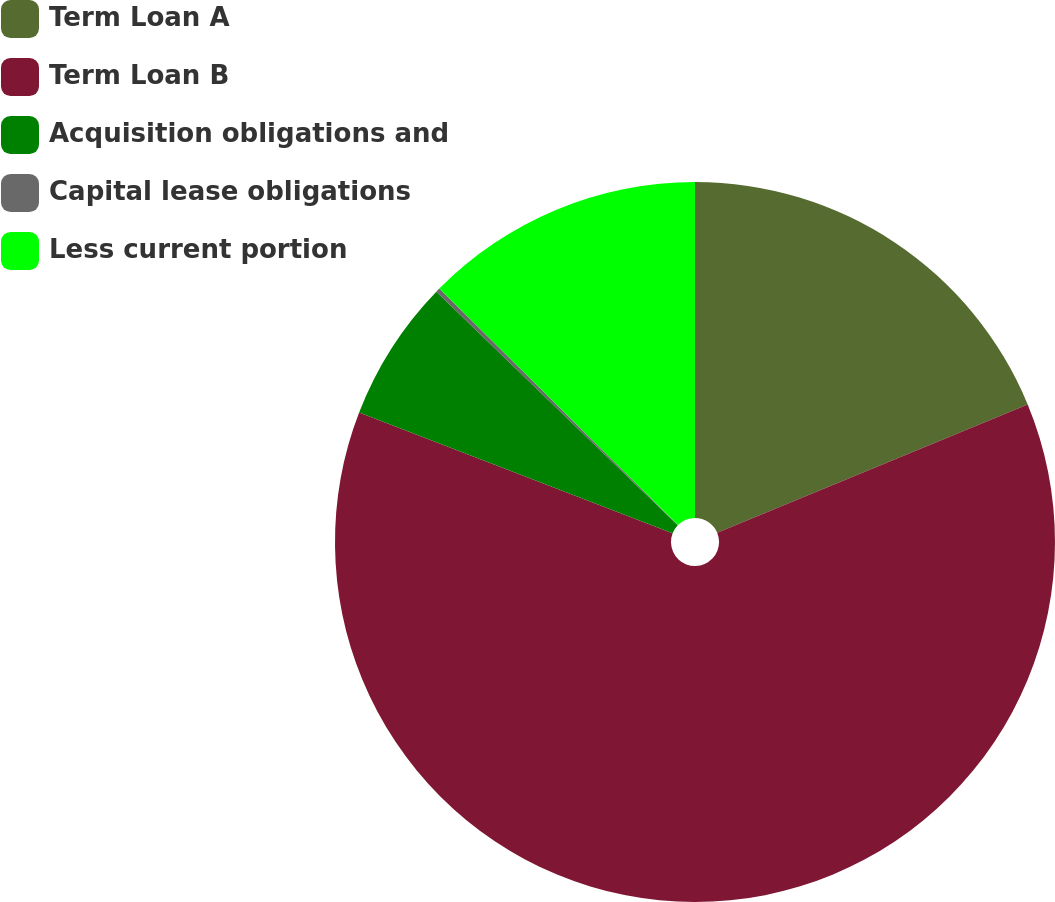Convert chart to OTSL. <chart><loc_0><loc_0><loc_500><loc_500><pie_chart><fcel>Term Loan A<fcel>Term Loan B<fcel>Acquisition obligations and<fcel>Capital lease obligations<fcel>Less current portion<nl><fcel>18.76%<fcel>62.1%<fcel>6.38%<fcel>0.19%<fcel>12.57%<nl></chart> 